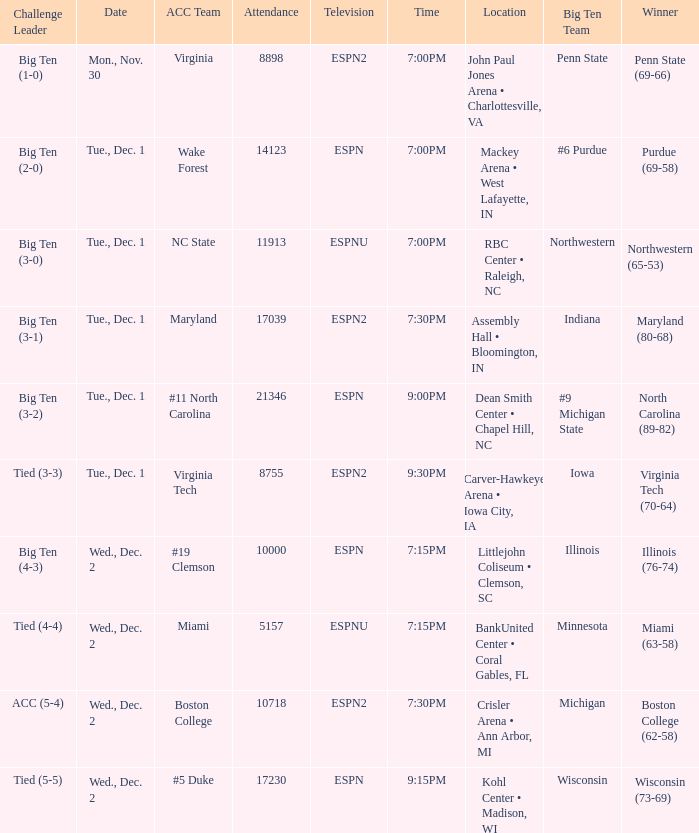Name the location for illinois Littlejohn Coliseum • Clemson, SC. 